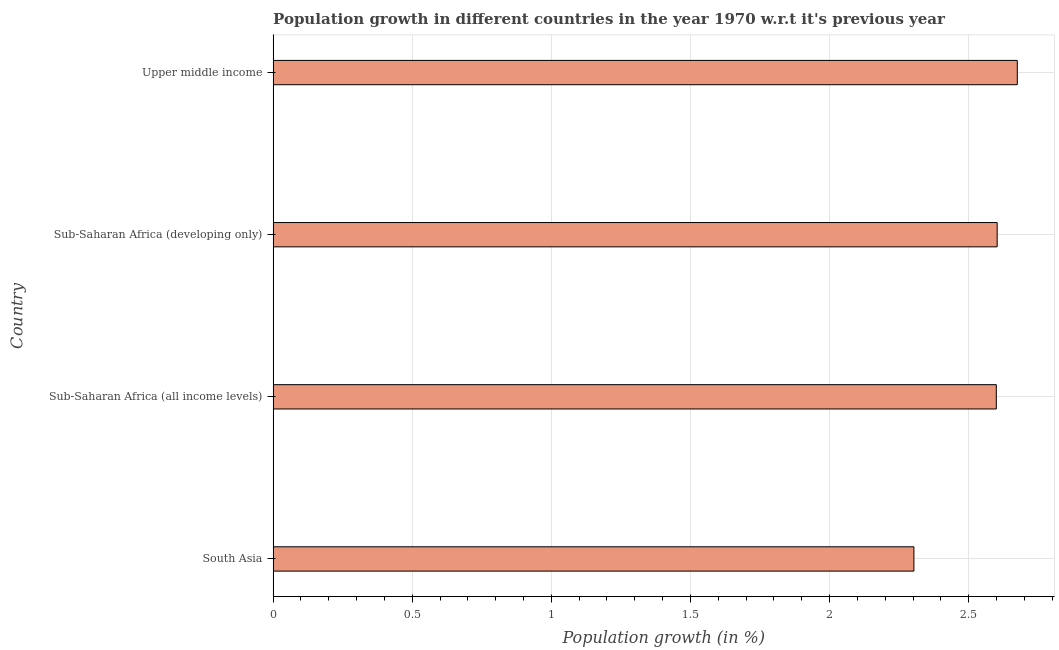Does the graph contain grids?
Provide a short and direct response. Yes. What is the title of the graph?
Your answer should be compact. Population growth in different countries in the year 1970 w.r.t it's previous year. What is the label or title of the X-axis?
Your answer should be very brief. Population growth (in %). What is the population growth in Sub-Saharan Africa (developing only)?
Your response must be concise. 2.6. Across all countries, what is the maximum population growth?
Provide a short and direct response. 2.67. Across all countries, what is the minimum population growth?
Give a very brief answer. 2.3. In which country was the population growth maximum?
Give a very brief answer. Upper middle income. What is the sum of the population growth?
Make the answer very short. 10.18. What is the difference between the population growth in Sub-Saharan Africa (all income levels) and Upper middle income?
Give a very brief answer. -0.07. What is the average population growth per country?
Give a very brief answer. 2.54. What is the median population growth?
Offer a terse response. 2.6. What is the ratio of the population growth in South Asia to that in Upper middle income?
Make the answer very short. 0.86. Is the population growth in South Asia less than that in Upper middle income?
Give a very brief answer. Yes. Is the difference between the population growth in South Asia and Upper middle income greater than the difference between any two countries?
Your answer should be compact. Yes. What is the difference between the highest and the second highest population growth?
Keep it short and to the point. 0.07. What is the difference between the highest and the lowest population growth?
Your answer should be very brief. 0.37. In how many countries, is the population growth greater than the average population growth taken over all countries?
Keep it short and to the point. 3. How many countries are there in the graph?
Ensure brevity in your answer.  4. What is the Population growth (in %) of South Asia?
Ensure brevity in your answer.  2.3. What is the Population growth (in %) of Sub-Saharan Africa (all income levels)?
Make the answer very short. 2.6. What is the Population growth (in %) in Sub-Saharan Africa (developing only)?
Keep it short and to the point. 2.6. What is the Population growth (in %) of Upper middle income?
Keep it short and to the point. 2.67. What is the difference between the Population growth (in %) in South Asia and Sub-Saharan Africa (all income levels)?
Your answer should be very brief. -0.3. What is the difference between the Population growth (in %) in South Asia and Sub-Saharan Africa (developing only)?
Offer a terse response. -0.3. What is the difference between the Population growth (in %) in South Asia and Upper middle income?
Make the answer very short. -0.37. What is the difference between the Population growth (in %) in Sub-Saharan Africa (all income levels) and Sub-Saharan Africa (developing only)?
Your response must be concise. -0. What is the difference between the Population growth (in %) in Sub-Saharan Africa (all income levels) and Upper middle income?
Your answer should be compact. -0.08. What is the difference between the Population growth (in %) in Sub-Saharan Africa (developing only) and Upper middle income?
Your response must be concise. -0.07. What is the ratio of the Population growth (in %) in South Asia to that in Sub-Saharan Africa (all income levels)?
Offer a terse response. 0.89. What is the ratio of the Population growth (in %) in South Asia to that in Sub-Saharan Africa (developing only)?
Offer a terse response. 0.89. What is the ratio of the Population growth (in %) in South Asia to that in Upper middle income?
Provide a short and direct response. 0.86. What is the ratio of the Population growth (in %) in Sub-Saharan Africa (all income levels) to that in Sub-Saharan Africa (developing only)?
Make the answer very short. 1. What is the ratio of the Population growth (in %) in Sub-Saharan Africa (all income levels) to that in Upper middle income?
Give a very brief answer. 0.97. 